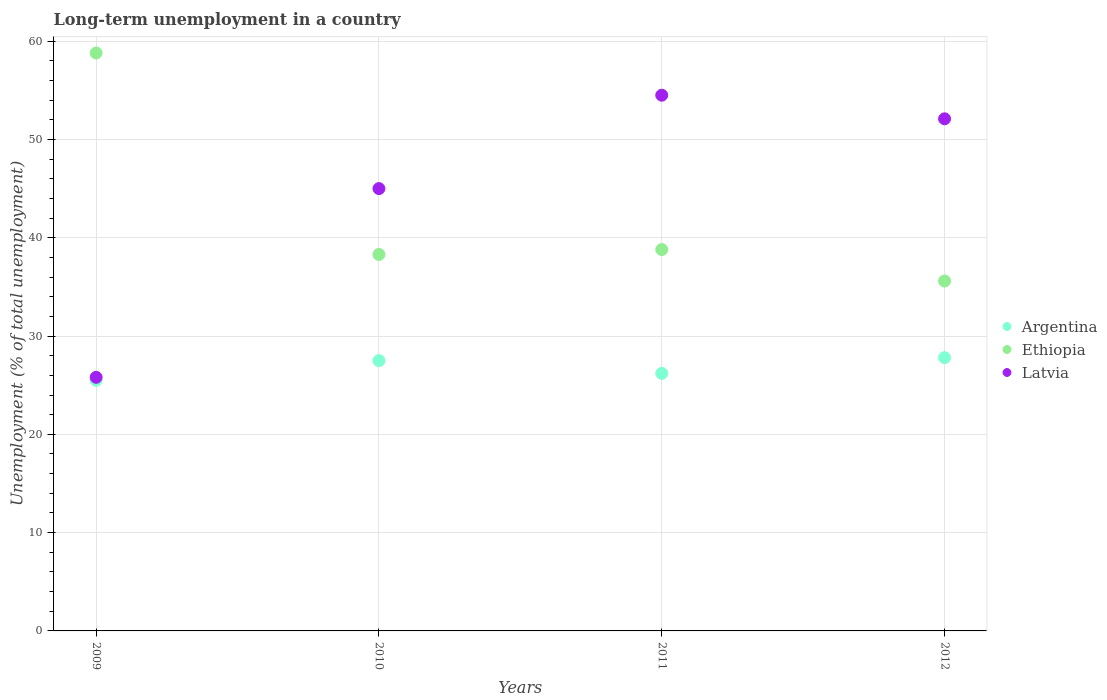How many different coloured dotlines are there?
Give a very brief answer. 3. Is the number of dotlines equal to the number of legend labels?
Your response must be concise. Yes. What is the percentage of long-term unemployed population in Latvia in 2010?
Ensure brevity in your answer.  45. Across all years, what is the maximum percentage of long-term unemployed population in Argentina?
Your answer should be compact. 27.8. Across all years, what is the minimum percentage of long-term unemployed population in Argentina?
Keep it short and to the point. 25.5. In which year was the percentage of long-term unemployed population in Latvia maximum?
Your answer should be compact. 2011. What is the total percentage of long-term unemployed population in Latvia in the graph?
Offer a very short reply. 177.4. What is the difference between the percentage of long-term unemployed population in Ethiopia in 2009 and that in 2011?
Make the answer very short. 20. What is the difference between the percentage of long-term unemployed population in Latvia in 2011 and the percentage of long-term unemployed population in Ethiopia in 2010?
Your answer should be very brief. 16.2. What is the average percentage of long-term unemployed population in Ethiopia per year?
Make the answer very short. 42.87. In the year 2010, what is the difference between the percentage of long-term unemployed population in Ethiopia and percentage of long-term unemployed population in Latvia?
Make the answer very short. -6.7. In how many years, is the percentage of long-term unemployed population in Ethiopia greater than 26 %?
Keep it short and to the point. 4. What is the ratio of the percentage of long-term unemployed population in Argentina in 2009 to that in 2012?
Give a very brief answer. 0.92. Is the percentage of long-term unemployed population in Ethiopia in 2010 less than that in 2012?
Ensure brevity in your answer.  No. What is the difference between the highest and the lowest percentage of long-term unemployed population in Argentina?
Keep it short and to the point. 2.3. Is it the case that in every year, the sum of the percentage of long-term unemployed population in Ethiopia and percentage of long-term unemployed population in Latvia  is greater than the percentage of long-term unemployed population in Argentina?
Provide a succinct answer. Yes. Does the percentage of long-term unemployed population in Argentina monotonically increase over the years?
Ensure brevity in your answer.  No. Is the percentage of long-term unemployed population in Argentina strictly less than the percentage of long-term unemployed population in Ethiopia over the years?
Ensure brevity in your answer.  Yes. What is the difference between two consecutive major ticks on the Y-axis?
Offer a terse response. 10. Are the values on the major ticks of Y-axis written in scientific E-notation?
Ensure brevity in your answer.  No. Does the graph contain grids?
Your answer should be very brief. Yes. How many legend labels are there?
Make the answer very short. 3. How are the legend labels stacked?
Your response must be concise. Vertical. What is the title of the graph?
Offer a terse response. Long-term unemployment in a country. What is the label or title of the X-axis?
Your answer should be compact. Years. What is the label or title of the Y-axis?
Ensure brevity in your answer.  Unemployment (% of total unemployment). What is the Unemployment (% of total unemployment) of Ethiopia in 2009?
Your answer should be very brief. 58.8. What is the Unemployment (% of total unemployment) of Latvia in 2009?
Keep it short and to the point. 25.8. What is the Unemployment (% of total unemployment) of Ethiopia in 2010?
Keep it short and to the point. 38.3. What is the Unemployment (% of total unemployment) of Argentina in 2011?
Offer a terse response. 26.2. What is the Unemployment (% of total unemployment) in Ethiopia in 2011?
Provide a short and direct response. 38.8. What is the Unemployment (% of total unemployment) in Latvia in 2011?
Offer a terse response. 54.5. What is the Unemployment (% of total unemployment) in Argentina in 2012?
Offer a very short reply. 27.8. What is the Unemployment (% of total unemployment) of Ethiopia in 2012?
Your answer should be very brief. 35.6. What is the Unemployment (% of total unemployment) in Latvia in 2012?
Provide a short and direct response. 52.1. Across all years, what is the maximum Unemployment (% of total unemployment) in Argentina?
Your answer should be compact. 27.8. Across all years, what is the maximum Unemployment (% of total unemployment) in Ethiopia?
Give a very brief answer. 58.8. Across all years, what is the maximum Unemployment (% of total unemployment) in Latvia?
Provide a succinct answer. 54.5. Across all years, what is the minimum Unemployment (% of total unemployment) of Ethiopia?
Keep it short and to the point. 35.6. Across all years, what is the minimum Unemployment (% of total unemployment) of Latvia?
Your response must be concise. 25.8. What is the total Unemployment (% of total unemployment) of Argentina in the graph?
Offer a very short reply. 107. What is the total Unemployment (% of total unemployment) in Ethiopia in the graph?
Make the answer very short. 171.5. What is the total Unemployment (% of total unemployment) of Latvia in the graph?
Provide a short and direct response. 177.4. What is the difference between the Unemployment (% of total unemployment) in Argentina in 2009 and that in 2010?
Offer a terse response. -2. What is the difference between the Unemployment (% of total unemployment) in Latvia in 2009 and that in 2010?
Give a very brief answer. -19.2. What is the difference between the Unemployment (% of total unemployment) of Ethiopia in 2009 and that in 2011?
Offer a very short reply. 20. What is the difference between the Unemployment (% of total unemployment) in Latvia in 2009 and that in 2011?
Offer a very short reply. -28.7. What is the difference between the Unemployment (% of total unemployment) of Argentina in 2009 and that in 2012?
Provide a short and direct response. -2.3. What is the difference between the Unemployment (% of total unemployment) in Ethiopia in 2009 and that in 2012?
Provide a succinct answer. 23.2. What is the difference between the Unemployment (% of total unemployment) of Latvia in 2009 and that in 2012?
Your answer should be very brief. -26.3. What is the difference between the Unemployment (% of total unemployment) in Ethiopia in 2010 and that in 2011?
Keep it short and to the point. -0.5. What is the difference between the Unemployment (% of total unemployment) in Latvia in 2010 and that in 2011?
Make the answer very short. -9.5. What is the difference between the Unemployment (% of total unemployment) in Argentina in 2010 and that in 2012?
Keep it short and to the point. -0.3. What is the difference between the Unemployment (% of total unemployment) in Latvia in 2010 and that in 2012?
Give a very brief answer. -7.1. What is the difference between the Unemployment (% of total unemployment) of Ethiopia in 2011 and that in 2012?
Make the answer very short. 3.2. What is the difference between the Unemployment (% of total unemployment) of Argentina in 2009 and the Unemployment (% of total unemployment) of Latvia in 2010?
Offer a terse response. -19.5. What is the difference between the Unemployment (% of total unemployment) of Ethiopia in 2009 and the Unemployment (% of total unemployment) of Latvia in 2011?
Ensure brevity in your answer.  4.3. What is the difference between the Unemployment (% of total unemployment) in Argentina in 2009 and the Unemployment (% of total unemployment) in Latvia in 2012?
Offer a terse response. -26.6. What is the difference between the Unemployment (% of total unemployment) in Argentina in 2010 and the Unemployment (% of total unemployment) in Latvia in 2011?
Your answer should be very brief. -27. What is the difference between the Unemployment (% of total unemployment) in Ethiopia in 2010 and the Unemployment (% of total unemployment) in Latvia in 2011?
Your response must be concise. -16.2. What is the difference between the Unemployment (% of total unemployment) in Argentina in 2010 and the Unemployment (% of total unemployment) in Ethiopia in 2012?
Keep it short and to the point. -8.1. What is the difference between the Unemployment (% of total unemployment) in Argentina in 2010 and the Unemployment (% of total unemployment) in Latvia in 2012?
Provide a succinct answer. -24.6. What is the difference between the Unemployment (% of total unemployment) in Ethiopia in 2010 and the Unemployment (% of total unemployment) in Latvia in 2012?
Keep it short and to the point. -13.8. What is the difference between the Unemployment (% of total unemployment) of Argentina in 2011 and the Unemployment (% of total unemployment) of Latvia in 2012?
Offer a terse response. -25.9. What is the average Unemployment (% of total unemployment) of Argentina per year?
Your response must be concise. 26.75. What is the average Unemployment (% of total unemployment) in Ethiopia per year?
Offer a terse response. 42.88. What is the average Unemployment (% of total unemployment) in Latvia per year?
Offer a very short reply. 44.35. In the year 2009, what is the difference between the Unemployment (% of total unemployment) of Argentina and Unemployment (% of total unemployment) of Ethiopia?
Offer a very short reply. -33.3. In the year 2009, what is the difference between the Unemployment (% of total unemployment) of Argentina and Unemployment (% of total unemployment) of Latvia?
Your answer should be very brief. -0.3. In the year 2010, what is the difference between the Unemployment (% of total unemployment) of Argentina and Unemployment (% of total unemployment) of Ethiopia?
Your answer should be very brief. -10.8. In the year 2010, what is the difference between the Unemployment (% of total unemployment) of Argentina and Unemployment (% of total unemployment) of Latvia?
Make the answer very short. -17.5. In the year 2011, what is the difference between the Unemployment (% of total unemployment) in Argentina and Unemployment (% of total unemployment) in Ethiopia?
Your response must be concise. -12.6. In the year 2011, what is the difference between the Unemployment (% of total unemployment) of Argentina and Unemployment (% of total unemployment) of Latvia?
Ensure brevity in your answer.  -28.3. In the year 2011, what is the difference between the Unemployment (% of total unemployment) of Ethiopia and Unemployment (% of total unemployment) of Latvia?
Ensure brevity in your answer.  -15.7. In the year 2012, what is the difference between the Unemployment (% of total unemployment) of Argentina and Unemployment (% of total unemployment) of Ethiopia?
Ensure brevity in your answer.  -7.8. In the year 2012, what is the difference between the Unemployment (% of total unemployment) of Argentina and Unemployment (% of total unemployment) of Latvia?
Give a very brief answer. -24.3. In the year 2012, what is the difference between the Unemployment (% of total unemployment) of Ethiopia and Unemployment (% of total unemployment) of Latvia?
Offer a very short reply. -16.5. What is the ratio of the Unemployment (% of total unemployment) in Argentina in 2009 to that in 2010?
Provide a succinct answer. 0.93. What is the ratio of the Unemployment (% of total unemployment) of Ethiopia in 2009 to that in 2010?
Offer a terse response. 1.54. What is the ratio of the Unemployment (% of total unemployment) of Latvia in 2009 to that in 2010?
Ensure brevity in your answer.  0.57. What is the ratio of the Unemployment (% of total unemployment) in Argentina in 2009 to that in 2011?
Give a very brief answer. 0.97. What is the ratio of the Unemployment (% of total unemployment) of Ethiopia in 2009 to that in 2011?
Give a very brief answer. 1.52. What is the ratio of the Unemployment (% of total unemployment) in Latvia in 2009 to that in 2011?
Give a very brief answer. 0.47. What is the ratio of the Unemployment (% of total unemployment) of Argentina in 2009 to that in 2012?
Offer a very short reply. 0.92. What is the ratio of the Unemployment (% of total unemployment) in Ethiopia in 2009 to that in 2012?
Your answer should be very brief. 1.65. What is the ratio of the Unemployment (% of total unemployment) of Latvia in 2009 to that in 2012?
Offer a very short reply. 0.5. What is the ratio of the Unemployment (% of total unemployment) of Argentina in 2010 to that in 2011?
Your response must be concise. 1.05. What is the ratio of the Unemployment (% of total unemployment) in Ethiopia in 2010 to that in 2011?
Offer a very short reply. 0.99. What is the ratio of the Unemployment (% of total unemployment) in Latvia in 2010 to that in 2011?
Provide a short and direct response. 0.83. What is the ratio of the Unemployment (% of total unemployment) in Argentina in 2010 to that in 2012?
Your answer should be very brief. 0.99. What is the ratio of the Unemployment (% of total unemployment) of Ethiopia in 2010 to that in 2012?
Your answer should be compact. 1.08. What is the ratio of the Unemployment (% of total unemployment) in Latvia in 2010 to that in 2012?
Your answer should be compact. 0.86. What is the ratio of the Unemployment (% of total unemployment) in Argentina in 2011 to that in 2012?
Your answer should be very brief. 0.94. What is the ratio of the Unemployment (% of total unemployment) of Ethiopia in 2011 to that in 2012?
Provide a short and direct response. 1.09. What is the ratio of the Unemployment (% of total unemployment) in Latvia in 2011 to that in 2012?
Make the answer very short. 1.05. What is the difference between the highest and the second highest Unemployment (% of total unemployment) of Argentina?
Ensure brevity in your answer.  0.3. What is the difference between the highest and the lowest Unemployment (% of total unemployment) of Ethiopia?
Ensure brevity in your answer.  23.2. What is the difference between the highest and the lowest Unemployment (% of total unemployment) in Latvia?
Your answer should be very brief. 28.7. 